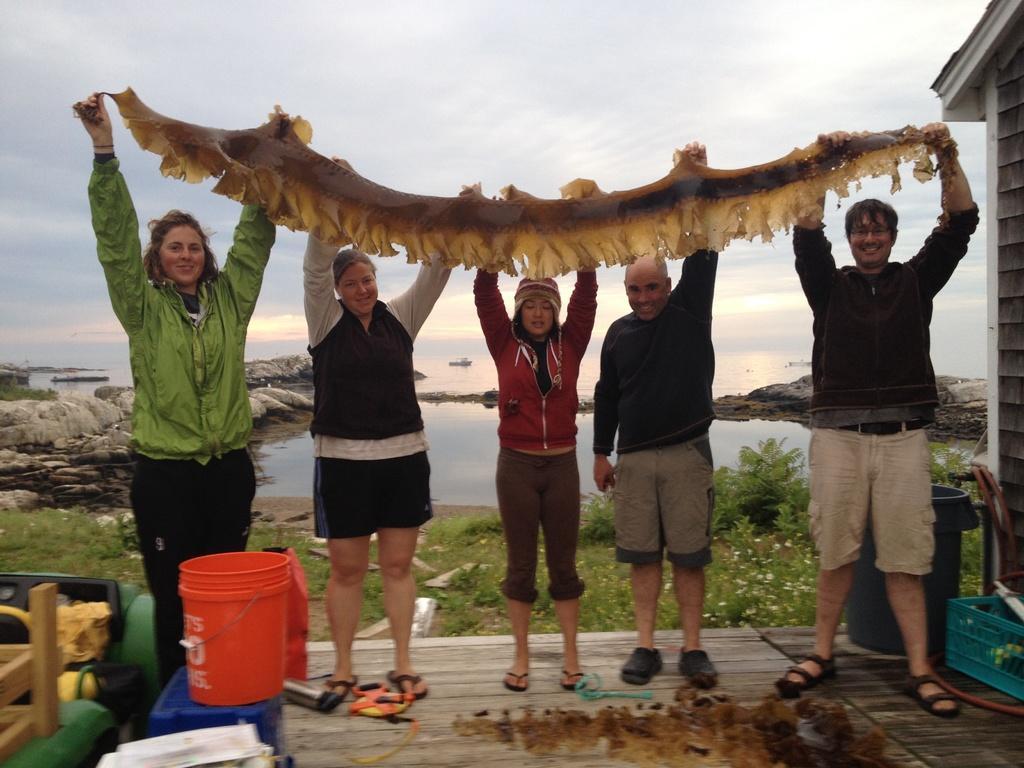In one or two sentences, can you explain what this image depicts? In this image in the front there are objects which are white, blue, red, green and brown in colour. In the center there are persons standing and holding object in their hands and smiling. In the background there is grass on the ground, there is water, there are stones. On the right side in the center there are baskets and there is a wall. On the left side there are objects which are black and yellow in colour. In the front on the floor there are objects. At the top we can see clouds in the sky. 